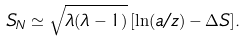Convert formula to latex. <formula><loc_0><loc_0><loc_500><loc_500>S _ { N } \simeq \sqrt { \lambda ( \lambda - 1 ) } \, [ \ln ( a / z ) - \Delta S ] .</formula> 